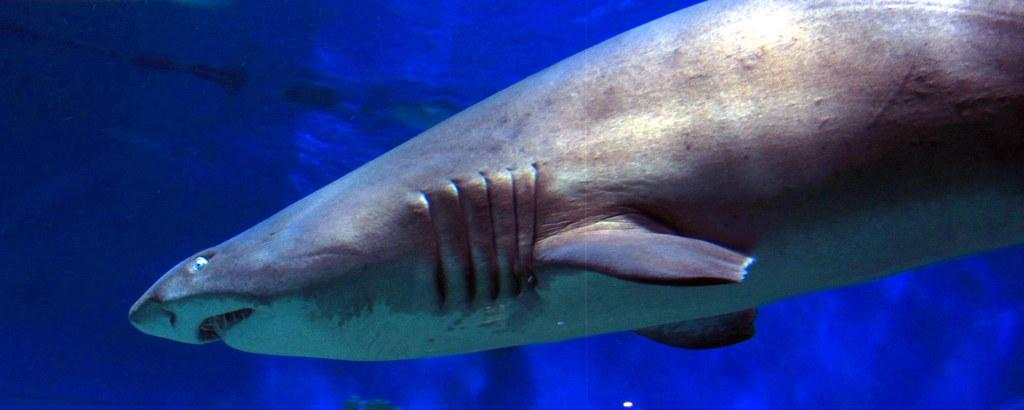What type of animal is in the image? There is a fish in the image. Where is the fish located? The fish is in water. What type of cushion is the fish sitting on in the image? There is no cushion present in the image, as the fish is in water. 